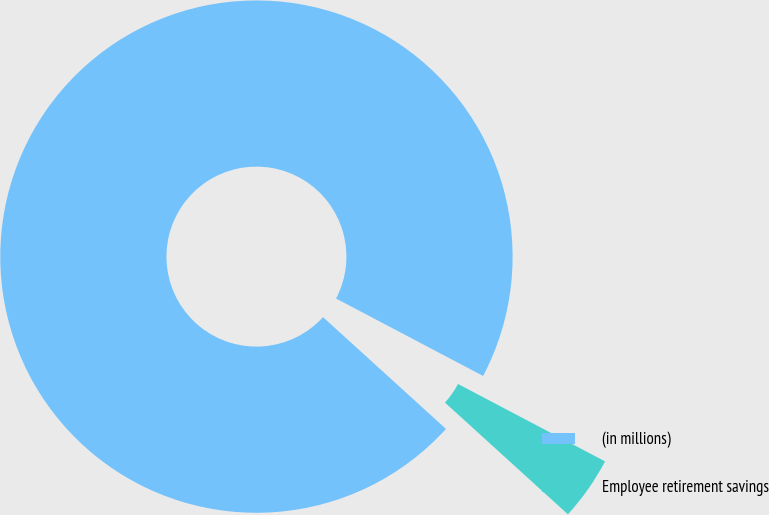<chart> <loc_0><loc_0><loc_500><loc_500><pie_chart><fcel>(in millions)<fcel>Employee retirement savings<nl><fcel>95.97%<fcel>4.03%<nl></chart> 